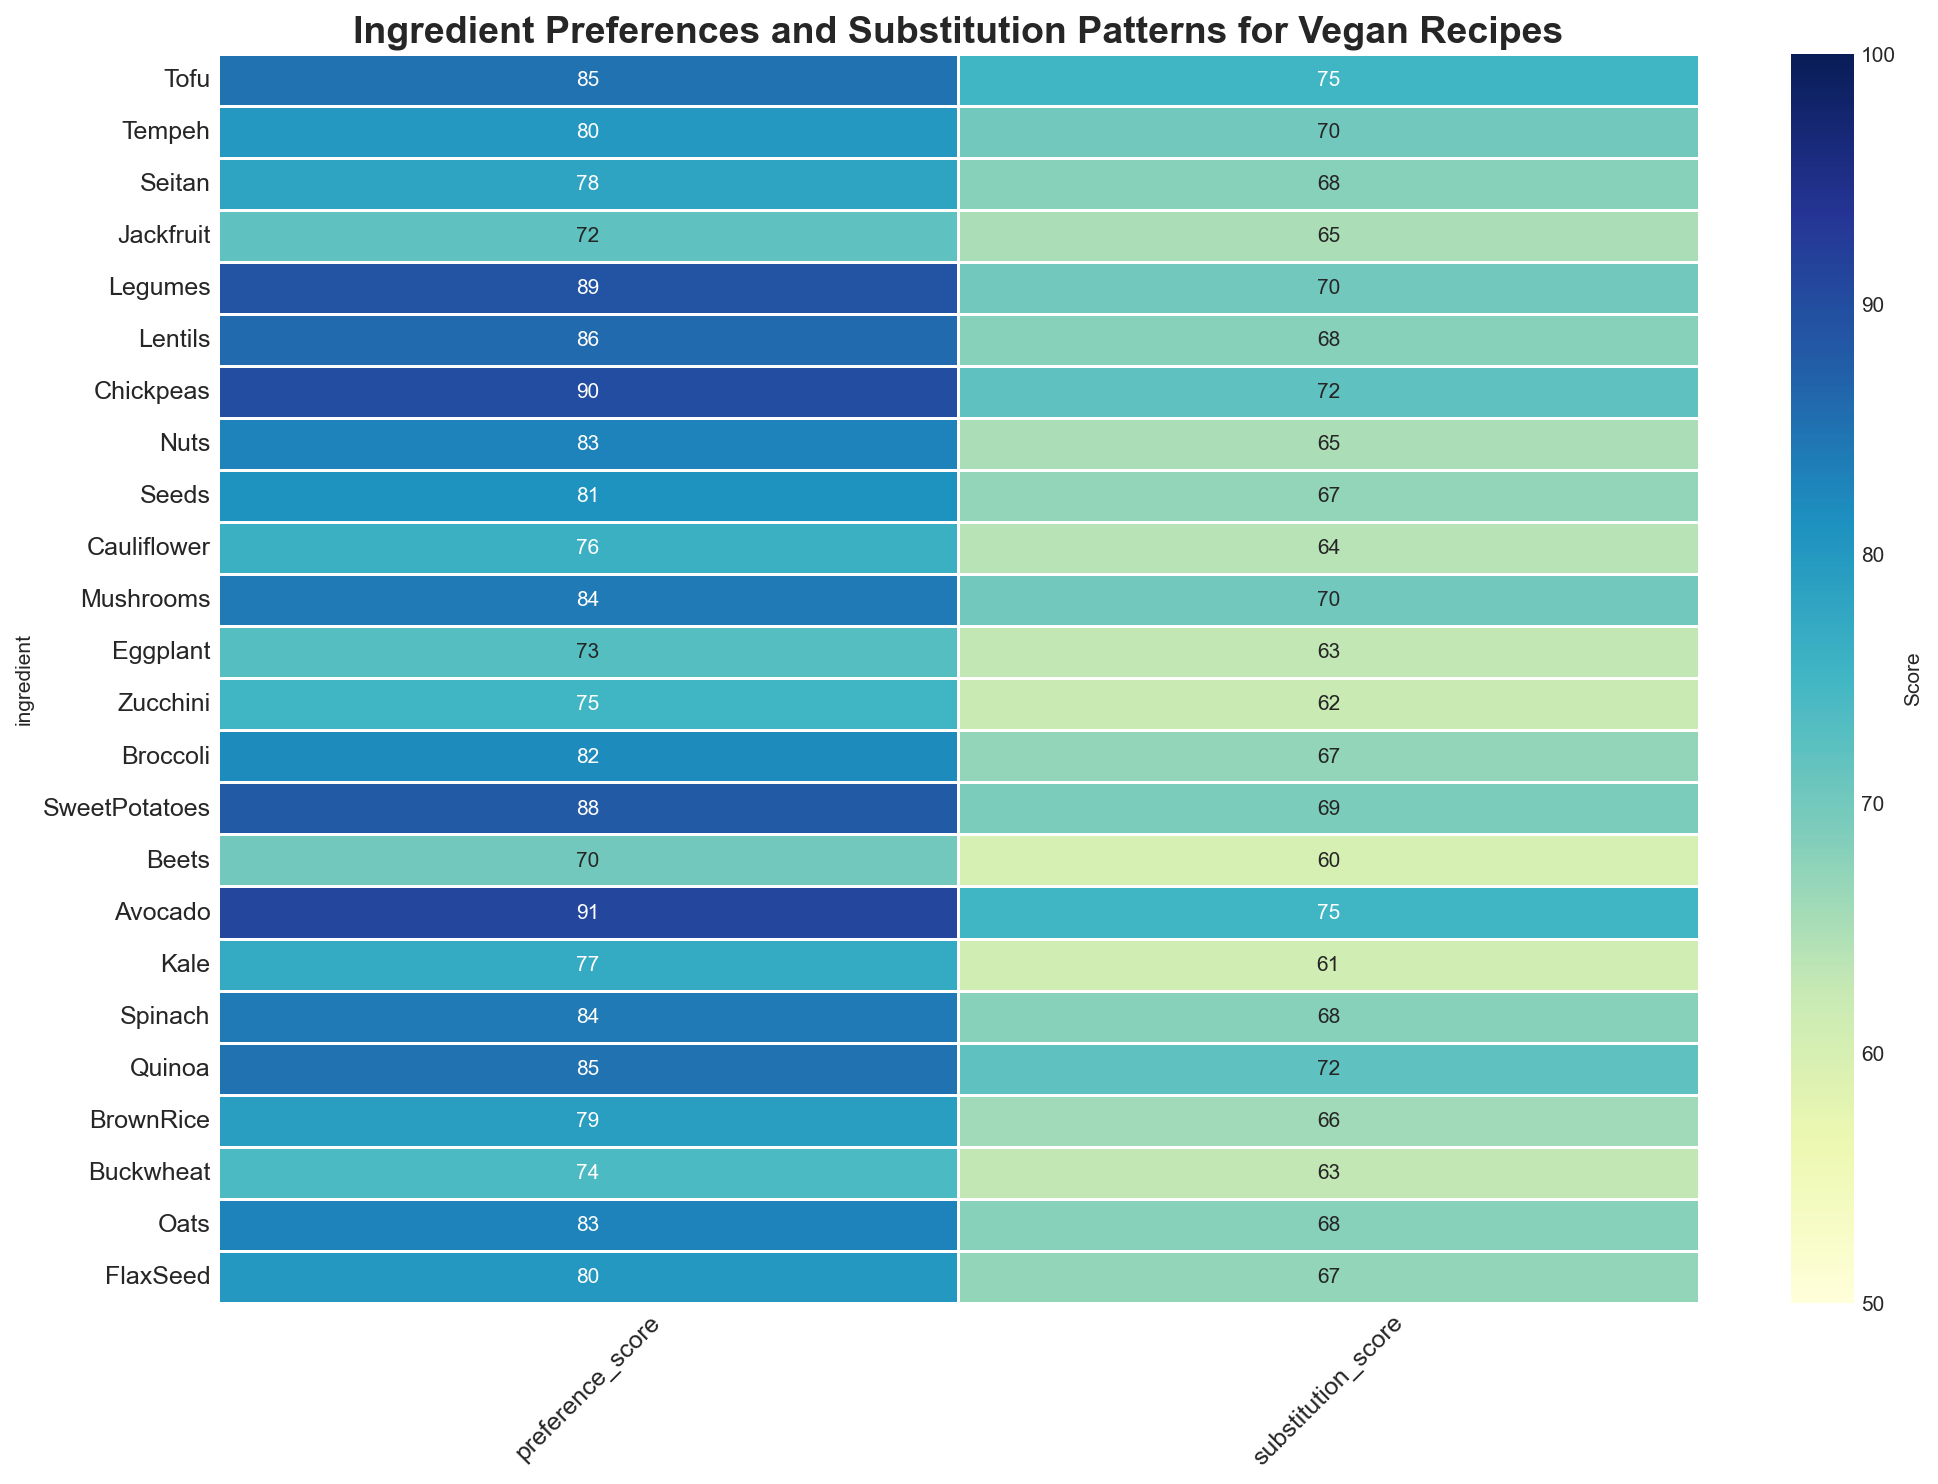What are the highest and lowest preference scores in the heatmap, and which ingredients do they correspond to? The highest preference score corresponds to Avocado (91) and the lowest preference score to Beets (70).
Answer: Highest: Avocado (91), Lowest: Beets (70) Is there any ingredient with a preference score equal to 85? By looking at the heatmap, Tofu and Quinoa both have a preference score of 85.
Answer: Tofu, Quinoa Which ingredient has the highest substitution score and what is that score? The highest substitution score is attributed to Avocado with a score of 75.
Answer: Avocado (75) Compare the preference scores of Chickpeas and Seitan. Which one is preferred more and by how much? Chickpeas have a preference score of 90, while Seitan has a preference score of 78. The difference in preference is 90 - 78 = 12.
Answer: Chickpeas by 12 Among the ingredients listed, which ones have a substitution score higher than 70? Checking the heatmap, the ingredients with substitution scores higher than 70 are Tofu, Chickpeas, Avocado, Quinoa.
Answer: Tofu, Chickpeas, Avocado, Quinoa Calculate the average preference score of Tofu, Tempeh, and Seitan. Adding the preference scores together (85 + 80 + 78) and then dividing by 3, (85+80+78)/3 = 81.
Answer: 81 How do the substitution scores for Mushrooms and Lentils compare? Both Mushrooms and Lentils have the same substitution score of 70.
Answer: Equal Which ingredient has a lower substitution score: Sweet Potatoes or Quinoa? Sweet Potatoes have a substitution score of 69 while Quinoa has a score of 72. Sweet Potatoes have a lower score.
Answer: Sweet Potatoes What is the total preference score if you sum the scores of Nuts, Seeds, and Cauliflower? Summing the preference scores: 83 (Nuts) + 81 (Seeds) + 76 (Cauliflower) = 240.
Answer: 240 Identify and compare the substitution scores for Broccoli and Brown Rice. Which ingredient has a higher score and by how much? Broccoli has a substitution score of 67, while Brown Rice has a substitution score of 66. Broccoli's score is higher by 1 point.
Answer: Broccoli by 1 